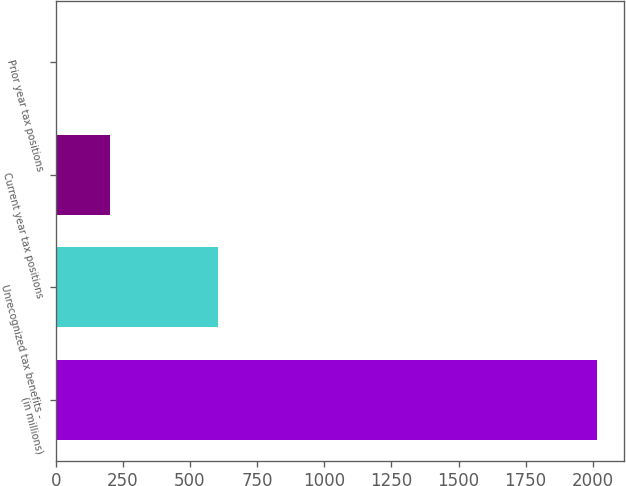<chart> <loc_0><loc_0><loc_500><loc_500><bar_chart><fcel>(in millions)<fcel>Unrecognized tax benefits -<fcel>Current year tax positions<fcel>Prior year tax positions<nl><fcel>2015<fcel>605.2<fcel>202.4<fcel>1<nl></chart> 